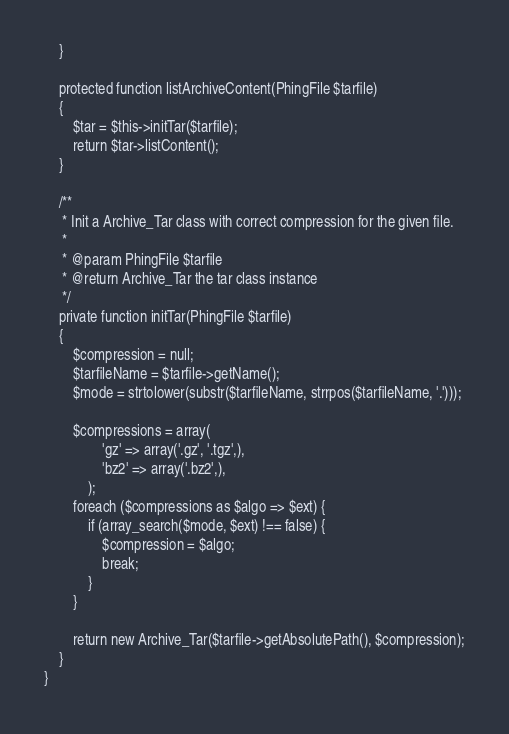Convert code to text. <code><loc_0><loc_0><loc_500><loc_500><_PHP_>    }

    protected function listArchiveContent(PhingFile $tarfile)
    {
        $tar = $this->initTar($tarfile);
        return $tar->listContent();
    }

    /**
     * Init a Archive_Tar class with correct compression for the given file.
     *
     * @param PhingFile $tarfile
     * @return Archive_Tar the tar class instance
     */
    private function initTar(PhingFile $tarfile)
    {
        $compression = null;
        $tarfileName = $tarfile->getName();
        $mode = strtolower(substr($tarfileName, strrpos($tarfileName, '.')));

        $compressions = array(
                'gz' => array('.gz', '.tgz',),
                'bz2' => array('.bz2',),
            );
        foreach ($compressions as $algo => $ext) {
            if (array_search($mode, $ext) !== false) {
                $compression = $algo;
                break;
            }
        }

        return new Archive_Tar($tarfile->getAbsolutePath(), $compression);
    }
}</code> 